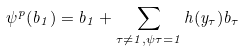Convert formula to latex. <formula><loc_0><loc_0><loc_500><loc_500>\psi ^ { p } ( b _ { 1 } ) = b _ { 1 } + \sum _ { \tau \not = 1 , \psi \tau = 1 } h ( y _ { \tau } ) b _ { \tau }</formula> 